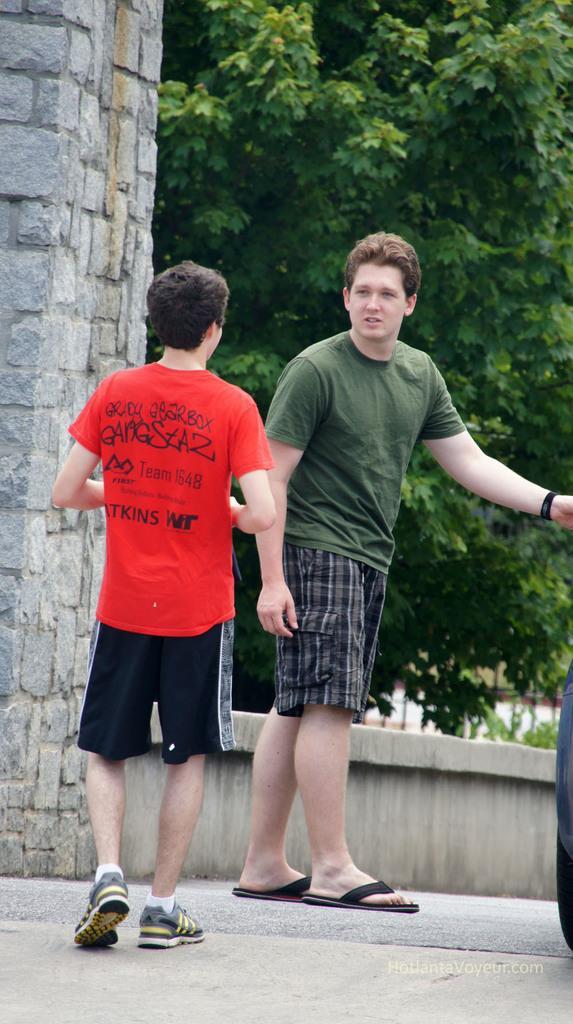Could you give a brief overview of what you see in this image? In this picture we can see two men standing on the road, wall and in the background we can see trees. 